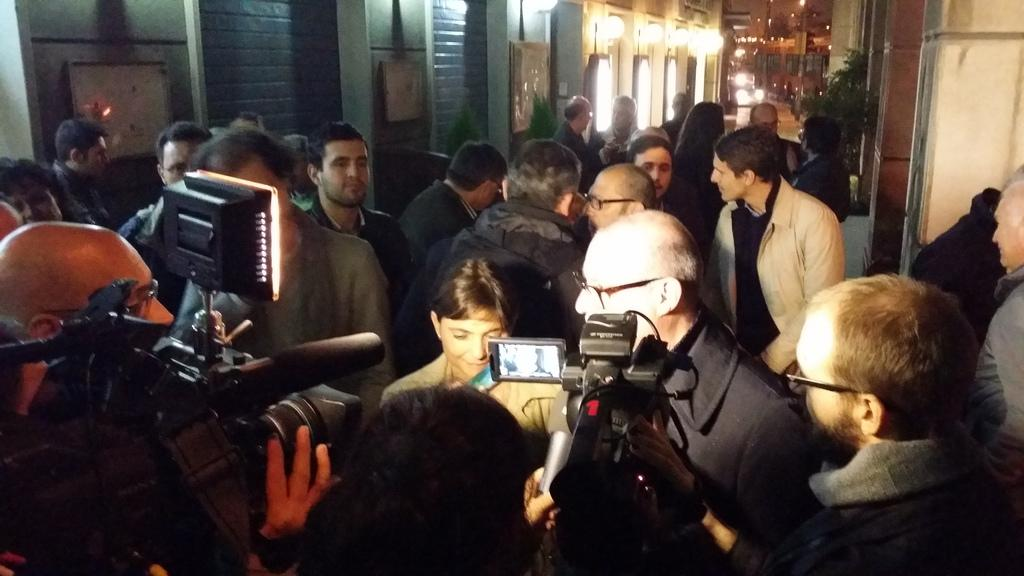What is the main subject of the image? The main subject of the image is a group of people. What are some of the people in the group doing? Some people in the group are holding cameras. What can be seen in the background of the image? There are lights and plants visible in the background of the image. How many fingers does the ghost have in the image? There is no ghost present in the image, so it is not possible to determine the number of fingers it might have. What type of pipe is being used by the people in the image? There is no pipe visible in the image; the people are holding cameras. 